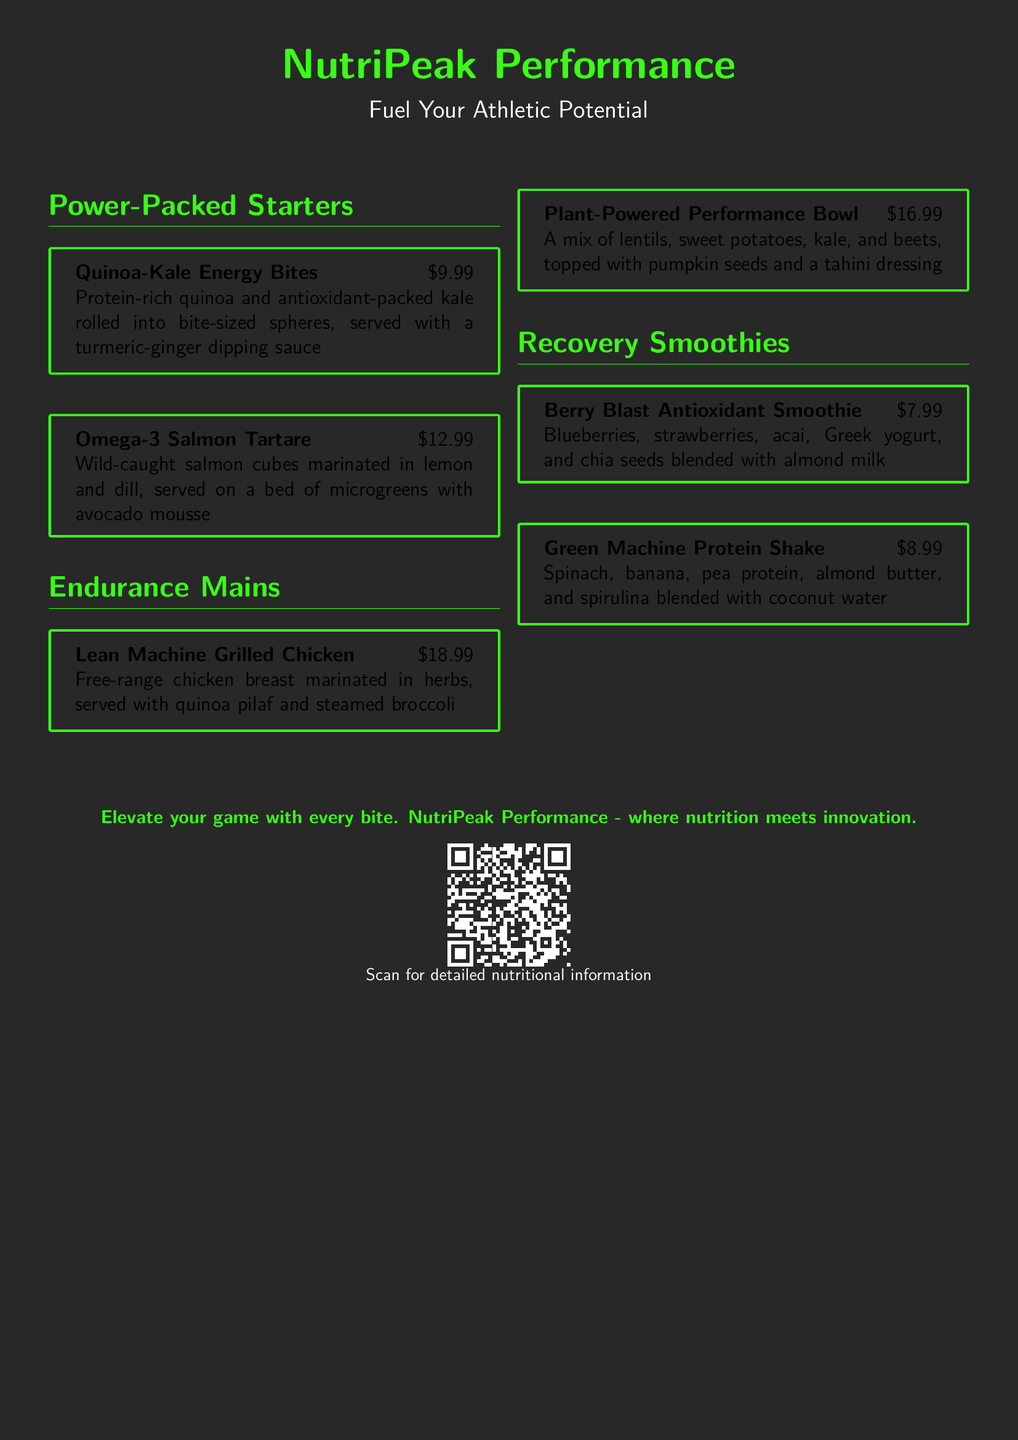What is the name of the restaurant? The name of the restaurant is prominently displayed at the top of the menu.
Answer: NutriPeak Performance What color is used for the title? The color of the title is mentioned in the document's formatting instructions.
Answer: Neongreen How much do the Quinoa-Kale Energy Bites cost? The price is listed directly next to the dish on the menu.
Answer: $9.99 What is the main ingredient in the Plant-Powered Performance Bowl? The primary ingredients are specified in the description of the dish.
Answer: Lentils Which smoothie contains almond butter? The smoothies are listed with their ingredients, making it easy to identify.
Answer: Green Machine Protein Shake What is served with the Lean Machine Grilled Chicken? The sides for the dish are specifically mentioned in the description.
Answer: Quinoa pilaf and steamed broccoli What type of dressing is used in the Plant-Powered Performance Bowl? The type of dressing is included in the description of the bowl.
Answer: Tahini dressing What is the description of the Omega-3 Salmon Tartare? The specifics of the dish are detailed in its description in the menu.
Answer: Wild-caught salmon cubes marinated in lemon and dill, served on a bed of microgreens with avocado mousse 